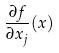Convert formula to latex. <formula><loc_0><loc_0><loc_500><loc_500>\frac { \partial f } { \partial x _ { j } } ( x )</formula> 